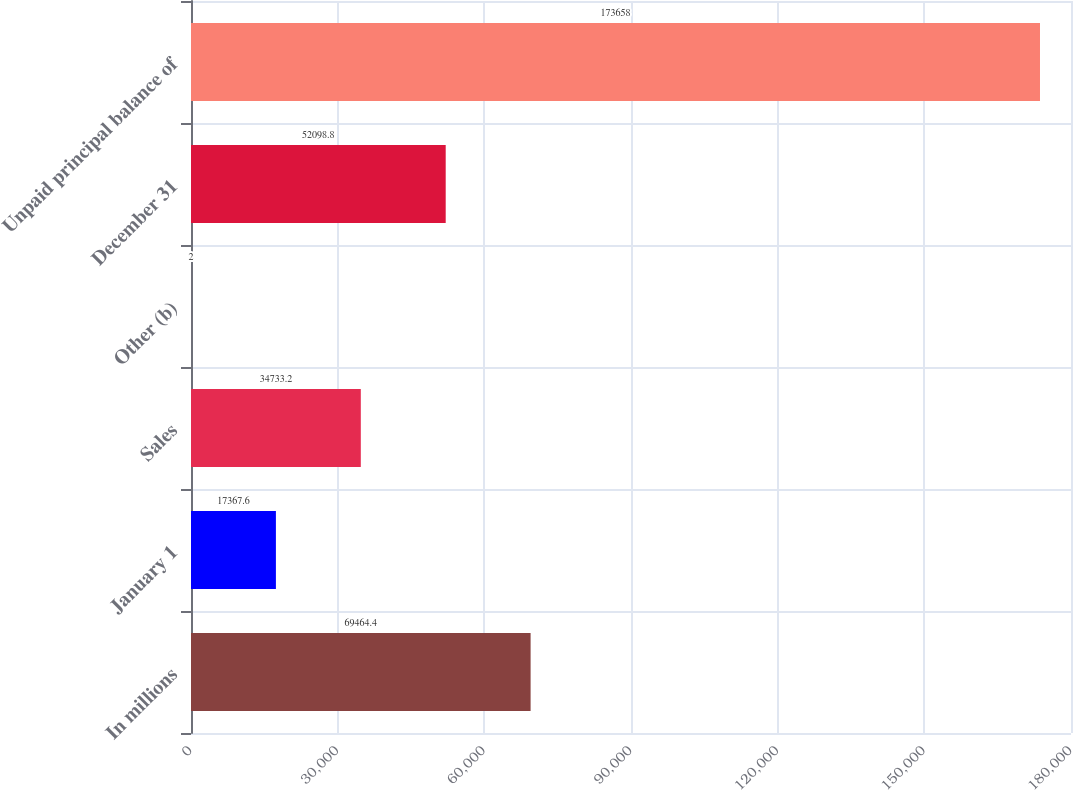Convert chart. <chart><loc_0><loc_0><loc_500><loc_500><bar_chart><fcel>In millions<fcel>January 1<fcel>Sales<fcel>Other (b)<fcel>December 31<fcel>Unpaid principal balance of<nl><fcel>69464.4<fcel>17367.6<fcel>34733.2<fcel>2<fcel>52098.8<fcel>173658<nl></chart> 